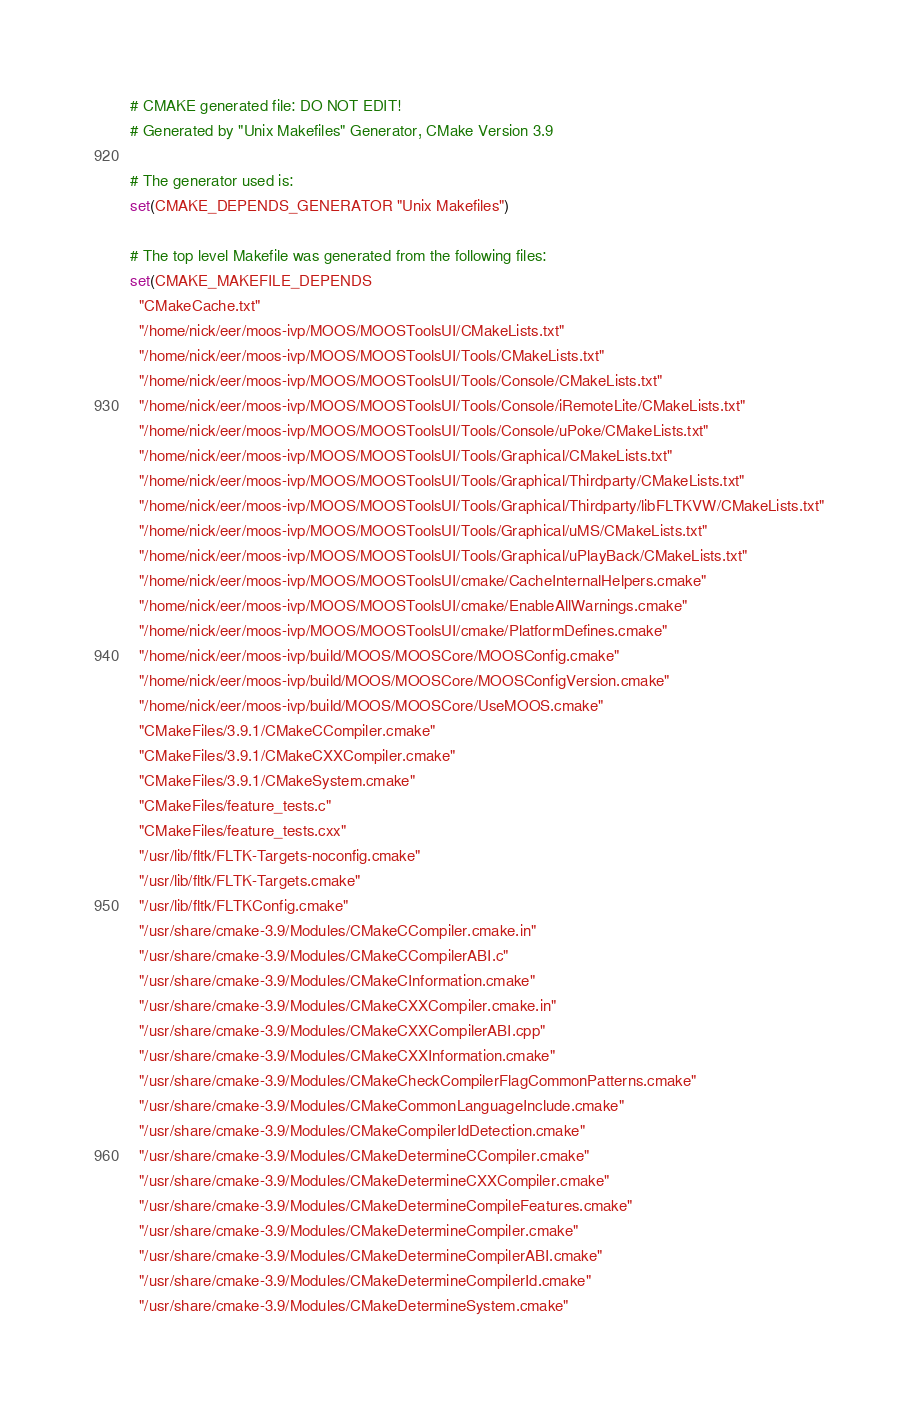<code> <loc_0><loc_0><loc_500><loc_500><_CMake_># CMAKE generated file: DO NOT EDIT!
# Generated by "Unix Makefiles" Generator, CMake Version 3.9

# The generator used is:
set(CMAKE_DEPENDS_GENERATOR "Unix Makefiles")

# The top level Makefile was generated from the following files:
set(CMAKE_MAKEFILE_DEPENDS
  "CMakeCache.txt"
  "/home/nick/eer/moos-ivp/MOOS/MOOSToolsUI/CMakeLists.txt"
  "/home/nick/eer/moos-ivp/MOOS/MOOSToolsUI/Tools/CMakeLists.txt"
  "/home/nick/eer/moos-ivp/MOOS/MOOSToolsUI/Tools/Console/CMakeLists.txt"
  "/home/nick/eer/moos-ivp/MOOS/MOOSToolsUI/Tools/Console/iRemoteLite/CMakeLists.txt"
  "/home/nick/eer/moos-ivp/MOOS/MOOSToolsUI/Tools/Console/uPoke/CMakeLists.txt"
  "/home/nick/eer/moos-ivp/MOOS/MOOSToolsUI/Tools/Graphical/CMakeLists.txt"
  "/home/nick/eer/moos-ivp/MOOS/MOOSToolsUI/Tools/Graphical/Thirdparty/CMakeLists.txt"
  "/home/nick/eer/moos-ivp/MOOS/MOOSToolsUI/Tools/Graphical/Thirdparty/libFLTKVW/CMakeLists.txt"
  "/home/nick/eer/moos-ivp/MOOS/MOOSToolsUI/Tools/Graphical/uMS/CMakeLists.txt"
  "/home/nick/eer/moos-ivp/MOOS/MOOSToolsUI/Tools/Graphical/uPlayBack/CMakeLists.txt"
  "/home/nick/eer/moos-ivp/MOOS/MOOSToolsUI/cmake/CacheInternalHelpers.cmake"
  "/home/nick/eer/moos-ivp/MOOS/MOOSToolsUI/cmake/EnableAllWarnings.cmake"
  "/home/nick/eer/moos-ivp/MOOS/MOOSToolsUI/cmake/PlatformDefines.cmake"
  "/home/nick/eer/moos-ivp/build/MOOS/MOOSCore/MOOSConfig.cmake"
  "/home/nick/eer/moos-ivp/build/MOOS/MOOSCore/MOOSConfigVersion.cmake"
  "/home/nick/eer/moos-ivp/build/MOOS/MOOSCore/UseMOOS.cmake"
  "CMakeFiles/3.9.1/CMakeCCompiler.cmake"
  "CMakeFiles/3.9.1/CMakeCXXCompiler.cmake"
  "CMakeFiles/3.9.1/CMakeSystem.cmake"
  "CMakeFiles/feature_tests.c"
  "CMakeFiles/feature_tests.cxx"
  "/usr/lib/fltk/FLTK-Targets-noconfig.cmake"
  "/usr/lib/fltk/FLTK-Targets.cmake"
  "/usr/lib/fltk/FLTKConfig.cmake"
  "/usr/share/cmake-3.9/Modules/CMakeCCompiler.cmake.in"
  "/usr/share/cmake-3.9/Modules/CMakeCCompilerABI.c"
  "/usr/share/cmake-3.9/Modules/CMakeCInformation.cmake"
  "/usr/share/cmake-3.9/Modules/CMakeCXXCompiler.cmake.in"
  "/usr/share/cmake-3.9/Modules/CMakeCXXCompilerABI.cpp"
  "/usr/share/cmake-3.9/Modules/CMakeCXXInformation.cmake"
  "/usr/share/cmake-3.9/Modules/CMakeCheckCompilerFlagCommonPatterns.cmake"
  "/usr/share/cmake-3.9/Modules/CMakeCommonLanguageInclude.cmake"
  "/usr/share/cmake-3.9/Modules/CMakeCompilerIdDetection.cmake"
  "/usr/share/cmake-3.9/Modules/CMakeDetermineCCompiler.cmake"
  "/usr/share/cmake-3.9/Modules/CMakeDetermineCXXCompiler.cmake"
  "/usr/share/cmake-3.9/Modules/CMakeDetermineCompileFeatures.cmake"
  "/usr/share/cmake-3.9/Modules/CMakeDetermineCompiler.cmake"
  "/usr/share/cmake-3.9/Modules/CMakeDetermineCompilerABI.cmake"
  "/usr/share/cmake-3.9/Modules/CMakeDetermineCompilerId.cmake"
  "/usr/share/cmake-3.9/Modules/CMakeDetermineSystem.cmake"</code> 